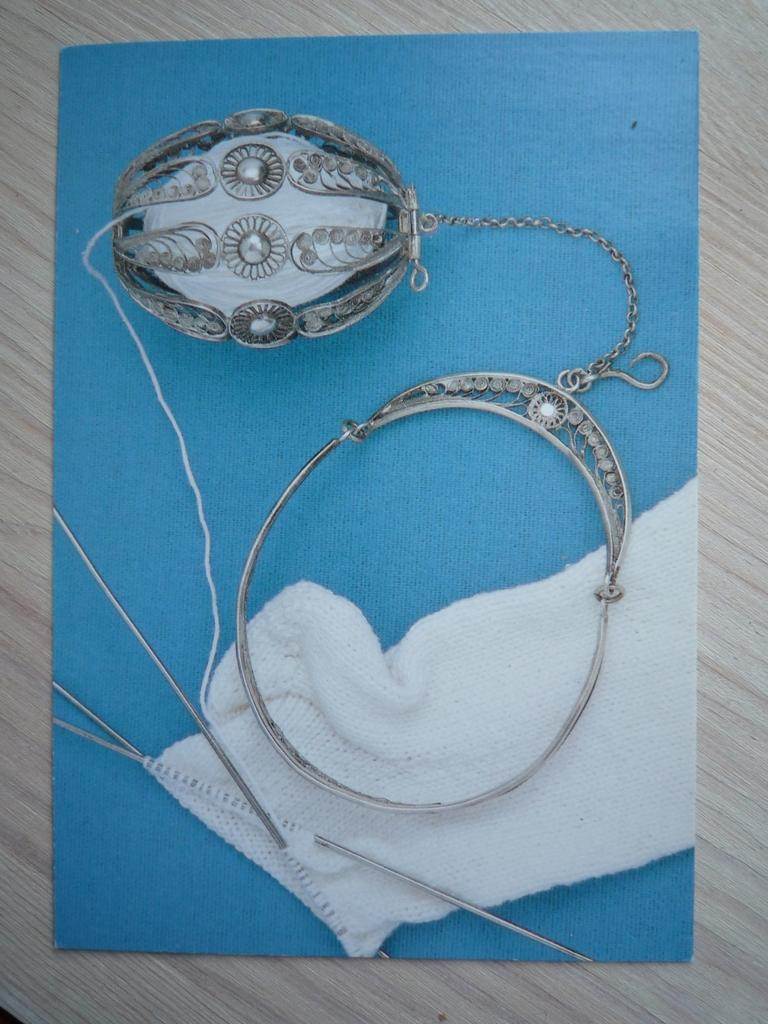What color is the paper in the image? The paper in the image is blue. What is the paper placed on? The paper is placed on a wooden surface. What is covering the paper? There is a cloth on the paper. What tools are present on the paper? There are needles and thread on the paper. What type of object is made of metal in the image? There is a metal object on the paper. How does the part join the bit in the image? There is no part or bit present in the image; the image features a blue paper with a cloth, needles, thread, and a metal object. 